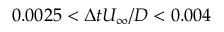Convert formula to latex. <formula><loc_0><loc_0><loc_500><loc_500>0 . 0 0 2 5 < \Delta t U _ { \infty } / D < 0 . 0 0 4</formula> 